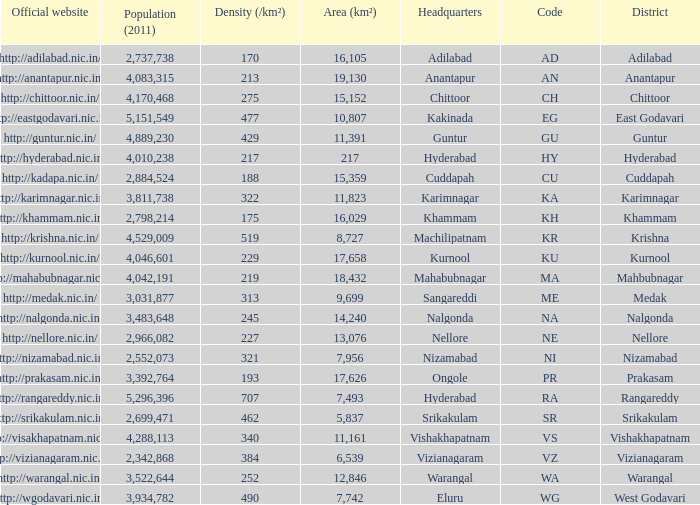What is the sum of the area values for districts having density over 462 and websites of http://krishna.nic.in/? 8727.0. 